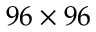Convert formula to latex. <formula><loc_0><loc_0><loc_500><loc_500>9 6 \times 9 6</formula> 